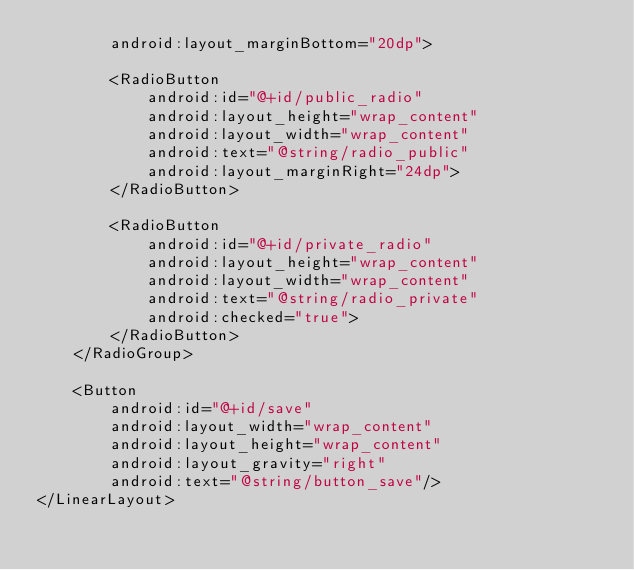Convert code to text. <code><loc_0><loc_0><loc_500><loc_500><_XML_>        android:layout_marginBottom="20dp">

        <RadioButton
            android:id="@+id/public_radio"
            android:layout_height="wrap_content"
            android:layout_width="wrap_content"
            android:text="@string/radio_public"
            android:layout_marginRight="24dp">
        </RadioButton>

        <RadioButton
            android:id="@+id/private_radio"
            android:layout_height="wrap_content"
            android:layout_width="wrap_content"
            android:text="@string/radio_private"
            android:checked="true">
        </RadioButton>
    </RadioGroup>

    <Button
        android:id="@+id/save"
        android:layout_width="wrap_content"
        android:layout_height="wrap_content"
        android:layout_gravity="right"
        android:text="@string/button_save"/>
</LinearLayout></code> 